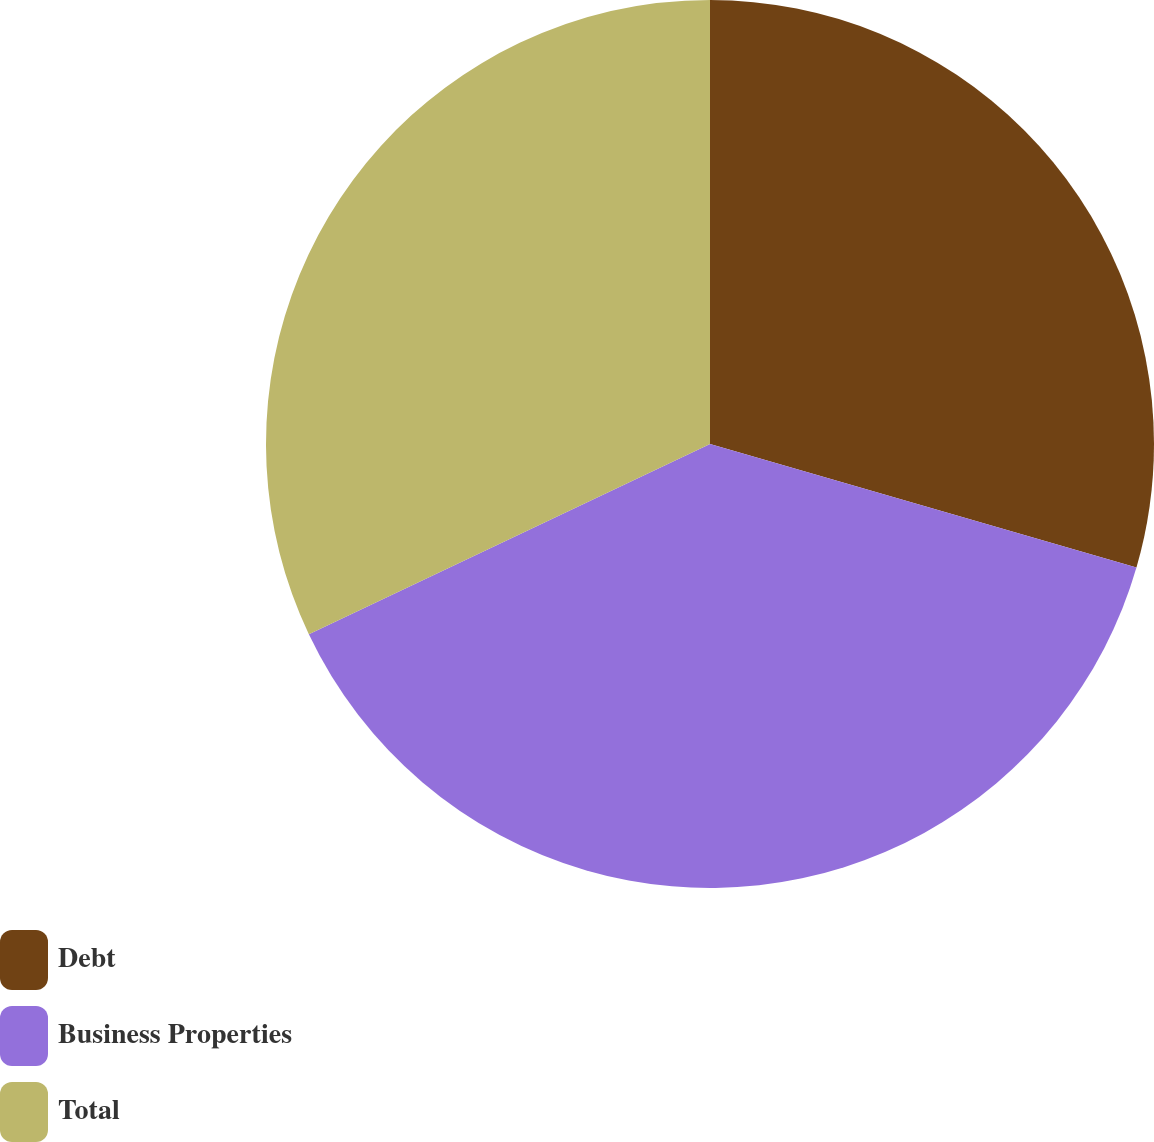Convert chart. <chart><loc_0><loc_0><loc_500><loc_500><pie_chart><fcel>Debt<fcel>Business Properties<fcel>Total<nl><fcel>29.49%<fcel>38.46%<fcel>32.05%<nl></chart> 